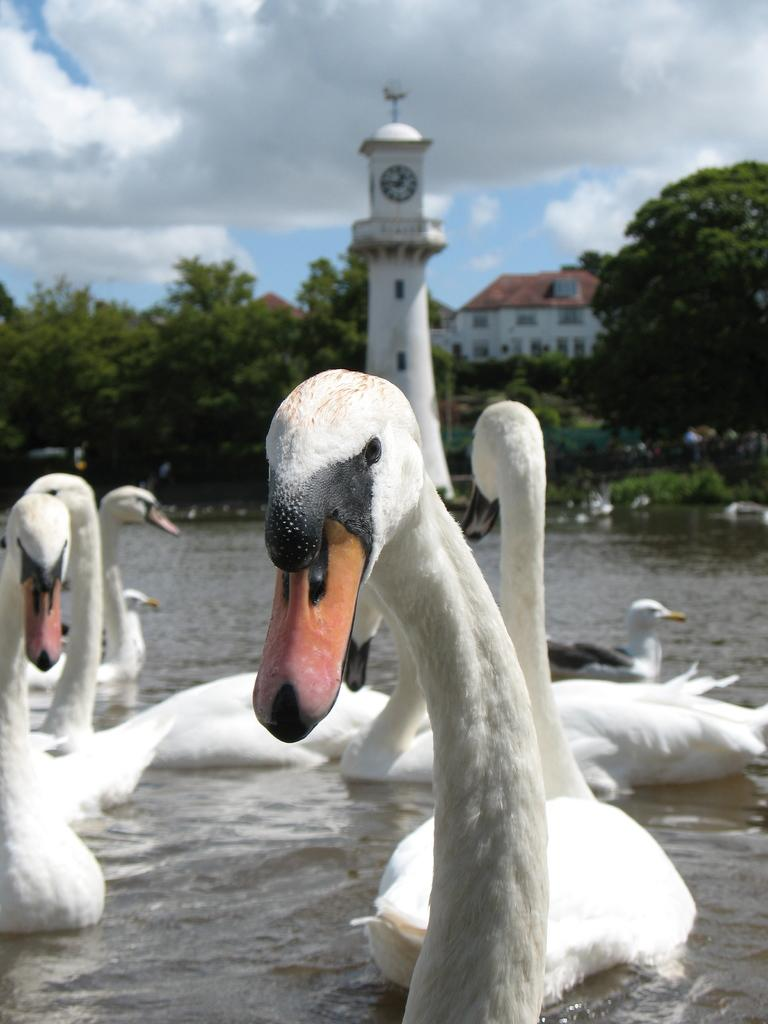What animals are on the water in the image? There are ducks on the water in the image. What can be seen in the background of the image? There are trees, a tower, and a house in the background of the image. Are the ducks wearing trousers in the image? No, the ducks are not wearing trousers in the image, as ducks do not wear clothing. 